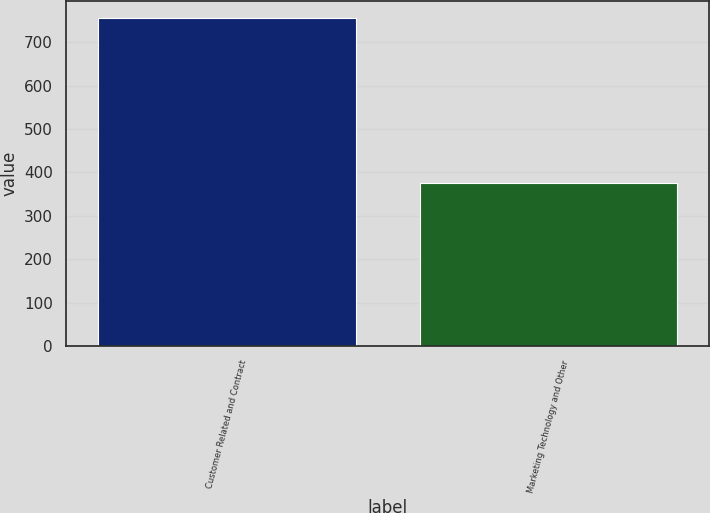Convert chart. <chart><loc_0><loc_0><loc_500><loc_500><bar_chart><fcel>Customer Related and Contract<fcel>Marketing Technology and Other<nl><fcel>757<fcel>376<nl></chart> 